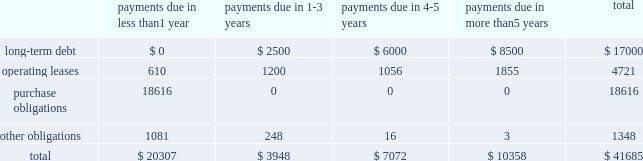Table of contents the table presents certain payments due by the company under contractual obligations with minimum firm commitments as of september 28 , 2013 and excludes amounts already recorded on the consolidated balance sheet , except for long-term debt ( in millions ) : lease commitments the company 2019s major facility leases are typically for terms not exceeding 10 years and generally provide renewal options for terms not exceeding five additional years .
Leases for retail space are for terms ranging from five to 20 years , the majority of which are for 10 years , and often contain multi-year renewal options .
As of september 28 , 2013 , the company 2019s total future minimum lease payments under noncancelable operating leases were $ 4.7 billion , of which $ 3.5 billion related to leases for retail space .
Purchase commitments with outsourcing partners and component suppliers the company utilizes several outsourcing partners to manufacture sub-assemblies for the company 2019s products and to perform final assembly and testing of finished products .
These outsourcing partners acquire components and build product based on demand information supplied by the company , which typically covers periods up to 150 days .
The company also obtains individual components for its products from a wide variety of individual suppliers .
Consistent with industry practice , the company acquires components through a combination of purchase orders , supplier contracts , and open orders based on projected demand information .
Where appropriate , the purchases are applied to inventory component prepayments that are outstanding with the respective supplier .
As of september 28 , 2013 , the company had outstanding off-balance sheet third- party manufacturing commitments and component purchase commitments of $ 18.6 billion .
Other obligations in addition to the off-balance sheet commitments mentioned above , the company had outstanding obligations of $ 1.3 billion as of september 28 , 2013 , that consisted mainly of commitments to acquire capital assets , including product tooling and manufacturing process equipment , and commitments related to advertising , research and development , internet and telecommunications services and other obligations .
The company 2019s other non-current liabilities in the consolidated balance sheets consist primarily of deferred tax liabilities , gross unrecognized tax benefits and the related gross interest and penalties .
As of september 28 , 2013 , the company had non-current deferred tax liabilities of $ 16.5 billion .
Additionally , as of september 28 , 2013 , the company had gross unrecognized tax benefits of $ 2.7 billion and an additional $ 590 million for gross interest and penalties classified as non-current liabilities .
At this time , the company is unable to make a reasonably reliable estimate of the timing of payments in individual years in connection with these tax liabilities ; therefore , such amounts are not included in the above contractual obligation table .
Indemnification the company generally does not indemnify end-users of its operating system and application software against legal claims that the software infringes third-party intellectual property rights .
Other agreements entered into by payments due in than 1 payments due in payments due in payments due in than 5 years total .

What percentage of certain payments due by the company under contractual obligations consisted of purchase obligations? 
Computations: (18616 / 41685)
Answer: 0.44659. 